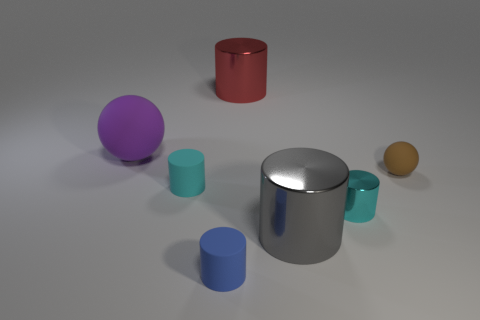Add 3 small brown matte objects. How many objects exist? 10 Subtract all gray cylinders. How many cylinders are left? 4 Subtract all brown spheres. How many spheres are left? 1 Subtract all balls. How many objects are left? 5 Subtract all yellow cylinders. Subtract all yellow balls. How many cylinders are left? 5 Subtract all green spheres. How many gray cylinders are left? 1 Subtract all small green rubber blocks. Subtract all large gray cylinders. How many objects are left? 6 Add 1 red cylinders. How many red cylinders are left? 2 Add 7 brown matte objects. How many brown matte objects exist? 8 Subtract 0 brown blocks. How many objects are left? 7 